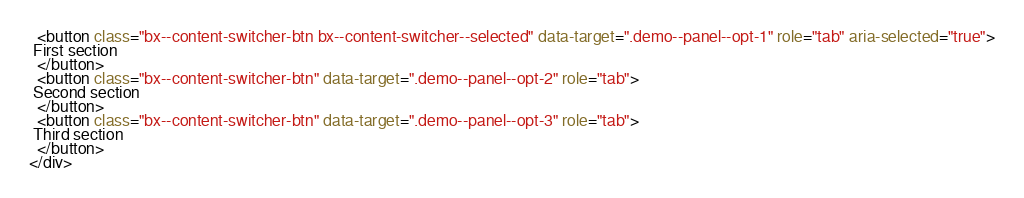<code> <loc_0><loc_0><loc_500><loc_500><_HTML_>  <button class="bx--content-switcher-btn bx--content-switcher--selected" data-target=".demo--panel--opt-1" role="tab" aria-selected="true">
 First section
  </button>
  <button class="bx--content-switcher-btn" data-target=".demo--panel--opt-2" role="tab">
 Second section
  </button>
  <button class="bx--content-switcher-btn" data-target=".demo--panel--opt-3" role="tab">
 Third section
  </button>
</div>
</code> 